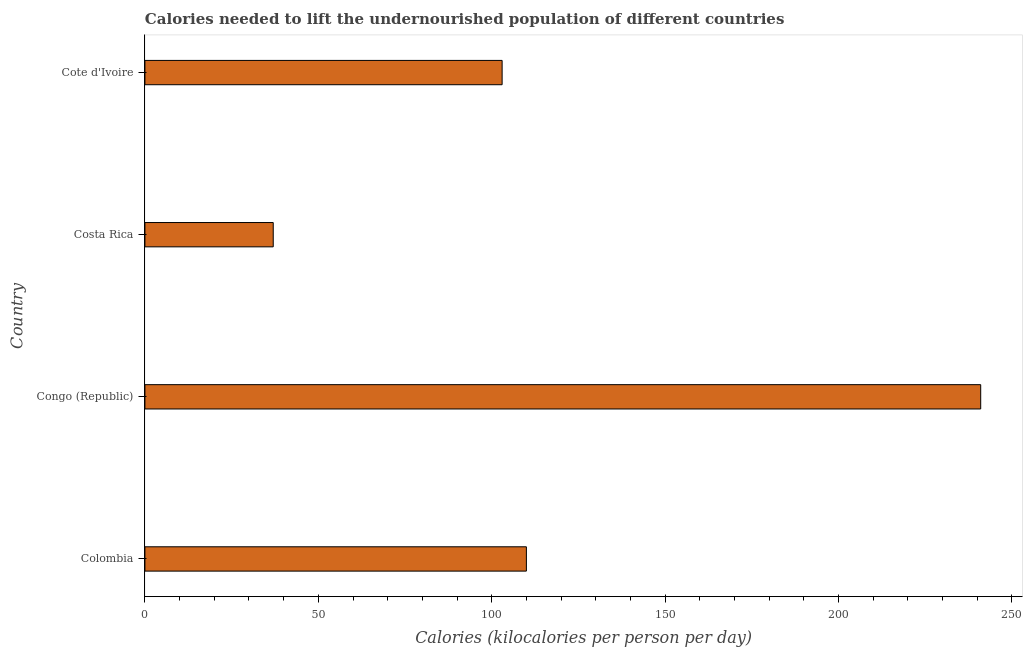Does the graph contain any zero values?
Offer a terse response. No. What is the title of the graph?
Offer a very short reply. Calories needed to lift the undernourished population of different countries. What is the label or title of the X-axis?
Give a very brief answer. Calories (kilocalories per person per day). What is the depth of food deficit in Cote d'Ivoire?
Keep it short and to the point. 103. Across all countries, what is the maximum depth of food deficit?
Ensure brevity in your answer.  241. In which country was the depth of food deficit maximum?
Make the answer very short. Congo (Republic). What is the sum of the depth of food deficit?
Make the answer very short. 491. What is the difference between the depth of food deficit in Costa Rica and Cote d'Ivoire?
Provide a short and direct response. -66. What is the average depth of food deficit per country?
Give a very brief answer. 122.75. What is the median depth of food deficit?
Ensure brevity in your answer.  106.5. In how many countries, is the depth of food deficit greater than 80 kilocalories?
Offer a very short reply. 3. What is the ratio of the depth of food deficit in Colombia to that in Cote d'Ivoire?
Your answer should be compact. 1.07. Is the depth of food deficit in Colombia less than that in Congo (Republic)?
Provide a succinct answer. Yes. What is the difference between the highest and the second highest depth of food deficit?
Provide a short and direct response. 131. What is the difference between the highest and the lowest depth of food deficit?
Keep it short and to the point. 204. In how many countries, is the depth of food deficit greater than the average depth of food deficit taken over all countries?
Provide a short and direct response. 1. How many bars are there?
Your answer should be very brief. 4. Are all the bars in the graph horizontal?
Provide a succinct answer. Yes. What is the difference between two consecutive major ticks on the X-axis?
Make the answer very short. 50. What is the Calories (kilocalories per person per day) in Colombia?
Your answer should be compact. 110. What is the Calories (kilocalories per person per day) in Congo (Republic)?
Your response must be concise. 241. What is the Calories (kilocalories per person per day) of Costa Rica?
Provide a short and direct response. 37. What is the Calories (kilocalories per person per day) of Cote d'Ivoire?
Provide a short and direct response. 103. What is the difference between the Calories (kilocalories per person per day) in Colombia and Congo (Republic)?
Your answer should be very brief. -131. What is the difference between the Calories (kilocalories per person per day) in Congo (Republic) and Costa Rica?
Your response must be concise. 204. What is the difference between the Calories (kilocalories per person per day) in Congo (Republic) and Cote d'Ivoire?
Offer a very short reply. 138. What is the difference between the Calories (kilocalories per person per day) in Costa Rica and Cote d'Ivoire?
Your response must be concise. -66. What is the ratio of the Calories (kilocalories per person per day) in Colombia to that in Congo (Republic)?
Keep it short and to the point. 0.46. What is the ratio of the Calories (kilocalories per person per day) in Colombia to that in Costa Rica?
Give a very brief answer. 2.97. What is the ratio of the Calories (kilocalories per person per day) in Colombia to that in Cote d'Ivoire?
Keep it short and to the point. 1.07. What is the ratio of the Calories (kilocalories per person per day) in Congo (Republic) to that in Costa Rica?
Provide a succinct answer. 6.51. What is the ratio of the Calories (kilocalories per person per day) in Congo (Republic) to that in Cote d'Ivoire?
Your answer should be compact. 2.34. What is the ratio of the Calories (kilocalories per person per day) in Costa Rica to that in Cote d'Ivoire?
Give a very brief answer. 0.36. 